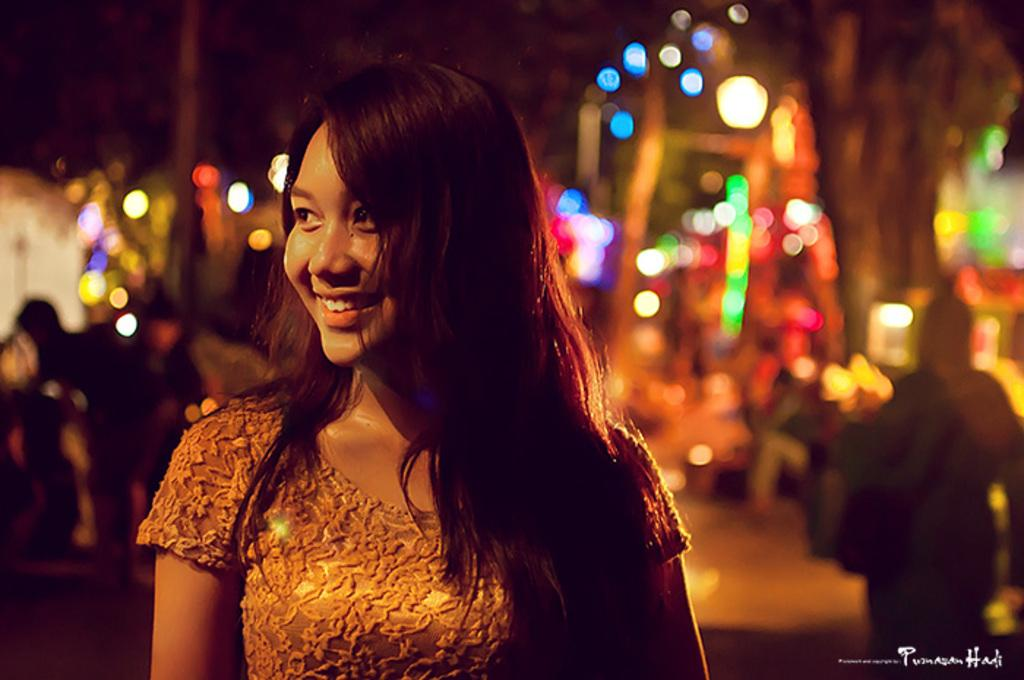What is located on the left side of the image? There is a woman on the left side of the image. What is the woman doing in the image? The woman is smiling. What can be seen behind the woman? There are lights visible behind the woman. How would you describe the background of the image? The background appears blurry. Where is the text located in the image? The text is in the bottom right corner of the image. How many friends are holding a basket in the image? There is no basket or friends present in the image. What is the cause of death for the woman in the image? There is no indication of death or any related information in the image. 